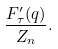<formula> <loc_0><loc_0><loc_500><loc_500>\frac { F ^ { \prime } _ { \tau } ( q ) } { Z _ { n } } .</formula> 